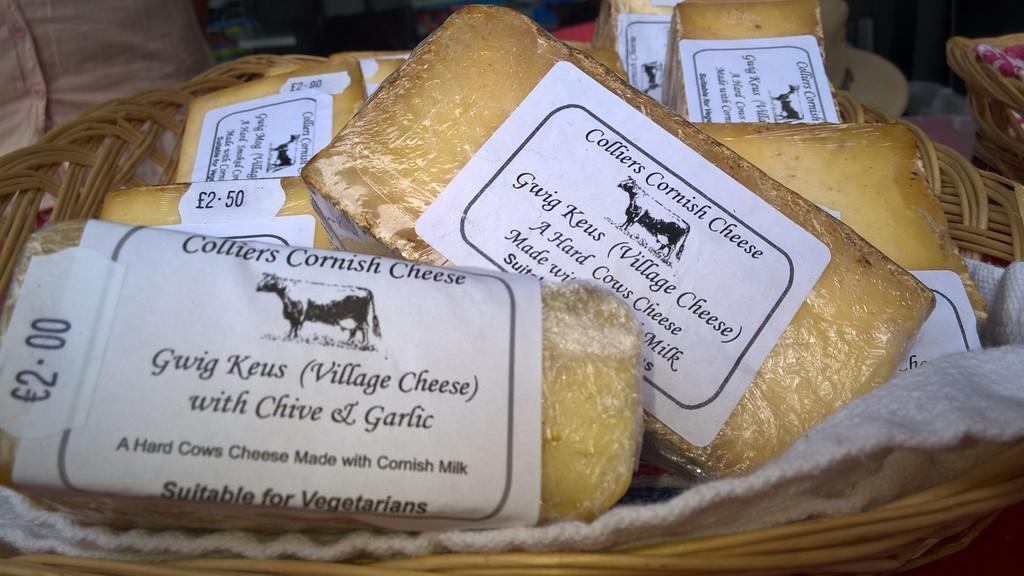Please provide a concise description of this image. In the image we can see wooden baskets. In it there are food items, wrapped in the plastic cover and label on it. On the label we can see a text and symbol of an animal. 